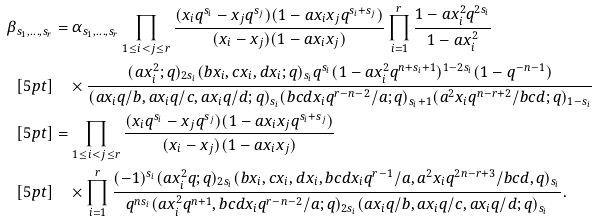Convert formula to latex. <formula><loc_0><loc_0><loc_500><loc_500>\beta _ { s _ { 1 } , \dots , s _ { r } } & = \alpha _ { s _ { 1 } , \dots , s _ { r } } \prod _ { 1 \leq i < j \leq r } \frac { ( x _ { i } q ^ { s _ { i } } - x _ { j } q ^ { s _ { j } } ) ( 1 - a x _ { i } x _ { j } q ^ { s _ { i } + s _ { j } } ) } { ( x _ { i } - x _ { j } ) ( 1 - a x _ { i } x _ { j } ) } \prod _ { i = 1 } ^ { r } \frac { 1 - a x _ { i } ^ { 2 } q ^ { 2 s _ { i } } } { 1 - a x _ { i } ^ { 2 } } \\ [ 5 p t ] & \quad \times \frac { ( a x _ { i } ^ { 2 } ; q ) _ { 2 s _ { i } } ( b x _ { i } , c x _ { i } , d x _ { i } ; q ) _ { s _ { i } } q ^ { s _ { i } } ( 1 - a x _ { i } ^ { 2 } q ^ { n + s _ { i } + 1 } ) ^ { 1 - 2 s _ { i } } ( 1 - q ^ { - n - 1 } ) } { ( a x _ { i } q / b , a x _ { i } q / c , a x _ { i } q / d ; q ) _ { s _ { i } } ( b c d x _ { i } q ^ { r - n - 2 } / a ; q ) _ { s _ { i } + 1 } ( a ^ { 2 } x _ { i } q ^ { n - r + 2 } / b c d ; q ) _ { 1 - s _ { i } } } \\ [ 5 p t ] & = \prod _ { 1 \leq i < j \leq r } \frac { ( x _ { i } q ^ { s _ { i } } - x _ { j } q ^ { s _ { j } } ) ( 1 - a x _ { i } x _ { j } q ^ { s _ { i } + s _ { j } } ) } { ( x _ { i } - x _ { j } ) ( 1 - a x _ { i } x _ { j } ) } \\ [ 5 p t ] & \quad \times \prod _ { i = 1 } ^ { r } \frac { ( - 1 ) ^ { s _ { i } } ( a x _ { i } ^ { 2 } q ; q ) _ { 2 s _ { i } } ( b x _ { i } , c x _ { i } , d x _ { i } , b c d x _ { i } q ^ { r - 1 } / a , a ^ { 2 } x _ { i } q ^ { 2 n - r + 3 } / b c d , q ) _ { s _ { i } } } { q ^ { n s _ { i } } ( a x _ { i } ^ { 2 } q ^ { n + 1 } , b c d x _ { i } q ^ { r - n - 2 } / a ; q ) _ { 2 s _ { i } } ( a x _ { i } q / b , a x _ { i } q / c , a x _ { i } q / d ; q ) _ { s _ { i } } } .</formula> 